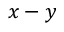Convert formula to latex. <formula><loc_0><loc_0><loc_500><loc_500>x - y</formula> 